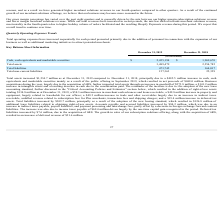According to Shopify's financial document, How much was the total assets as at December 31, 2019? According to the financial document, 3,489,479 (in thousands). The relevant text states: "Total assets 3,489,479 2,254,785..." Also, How much was the total liabilities as at December 31, 2019? According to the financial document, 473,745 (in thousands). The relevant text states: "Total liabilities 473,745 164,017..." Also, How much was the total non-current liabilities as at December 2019? According to the financial document, 157,363 (in thousands). The relevant text states: "Total non-current liabilities 157,363 25,329..." Also, can you calculate: What was the average cash, cash equivalents and marketable securities for 2018 and 2019? To answer this question, I need to perform calculations using the financial data. The calculation is: ($2,455,194+$1,969,670)/2, which equals 2212432 (in thousands). This is based on the information: "uivalents and marketable securities $ 2,455,194 $ 1,969,670 ash, cash equivalents and marketable securities $ 2,455,194 $ 1,969,670..." The key data points involved are: 1,969,670, 2,455,194. Also, can you calculate: What is the average total assets for 2018 and 2019? To answer this question, I need to perform calculations using the financial data. The calculation is: (3,489,479+2,254,785)/2, which equals 2872132 (in thousands). This is based on the information: "Total assets 3,489,479 2,254,785 Total assets 3,489,479 2,254,785..." The key data points involved are: 2,254,785, 3,489,479. Also, can you calculate: What is the average total liabilities for 2018 and 2019? To answer this question, I need to perform calculations using the financial data. The calculation is: (473,745+164,017)/2, which equals 318881 (in thousands). This is based on the information: "Total liabilities 473,745 164,017 Total liabilities 473,745 164,017..." The key data points involved are: 164,017, 473,745. 